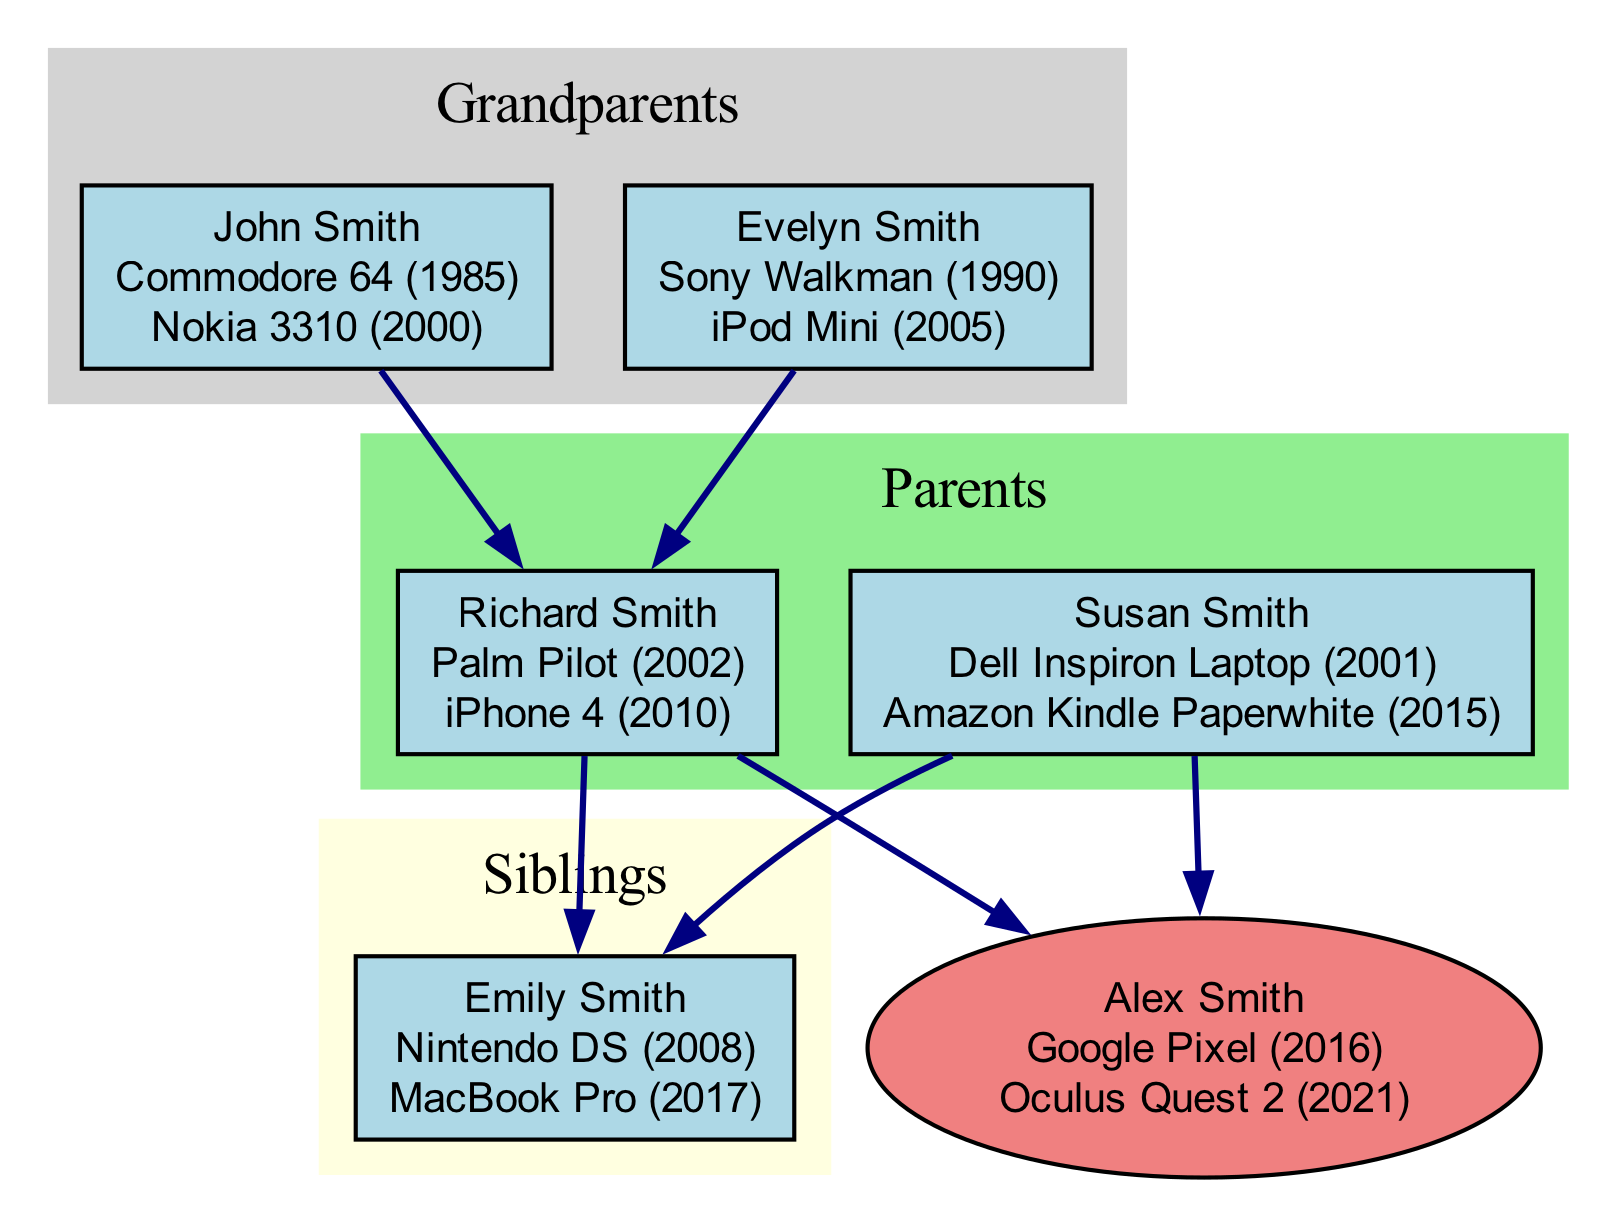What gadgets did John Smith adopt? John Smith is one of the grandparents in the diagram. According to the information, he adopted the Commodore 64 in 1985 and the Nokia 3310 in 2000.
Answer: Commodore 64, Nokia 3310 How many tech gadgets did Susan Smith adopt? Susan Smith is one of the parents in the diagram. She is shown to have adopted two tech gadgets: the Dell Inspiron Laptop in 2001 and the Amazon Kindle Paperwhite in 2015. Thus, the number of gadgets she adopted is two.
Answer: 2 What is the connection between Alex Smith and Richard Smith? Alex Smith is the self node in the diagram, and Richard Smith is one of the parents. The connection is a direct parental relationship, indicating that Richard is Alex's father.
Answer: Father Which tech gadget was adopted first in the family tree? Looking at all the tech gadgets in the diagram, the earliest one is the Commodore 64, which was adopted by John Smith in 1985. This was before all other gadgets mentioned in the diagram.
Answer: Commodore 64 How many siblings does Alex Smith have? In the family tree, under the siblings section, there is one sibling mentioned: Emily Smith. This indicates that Alex Smith has one sibling.
Answer: 1 What gadget did Emily Smith adopt in 2017? According to the sibling section, Emily Smith adopted the MacBook Pro in 2017, as stated in the diagram.
Answer: MacBook Pro Which gadget was shared by both Richard Smith and Susan Smith from their parents? Both Richard Smith and Susan Smith are descendants of the same grandparents; however, the question implies looking for a gadget that influenced both their tech adoption. Upon reviewing their gadgets, there is no direct shared gadget, but they did adopt gadgets following the lineage established by their parents.
Answer: None What is the most recent gadget adopted by Alex Smith? Looking at Alex Smith's section, the most recent gadget listed is the Oculus Quest 2, which was adopted in 2021.
Answer: Oculus Quest 2 Which generation does the Dell Inspiron Laptop belong to? The Dell Inspiron Laptop is associated with Susan Smith, who belongs to the parents' generation in the diagram. Thus, it belongs to the parents' generation.
Answer: Parents 